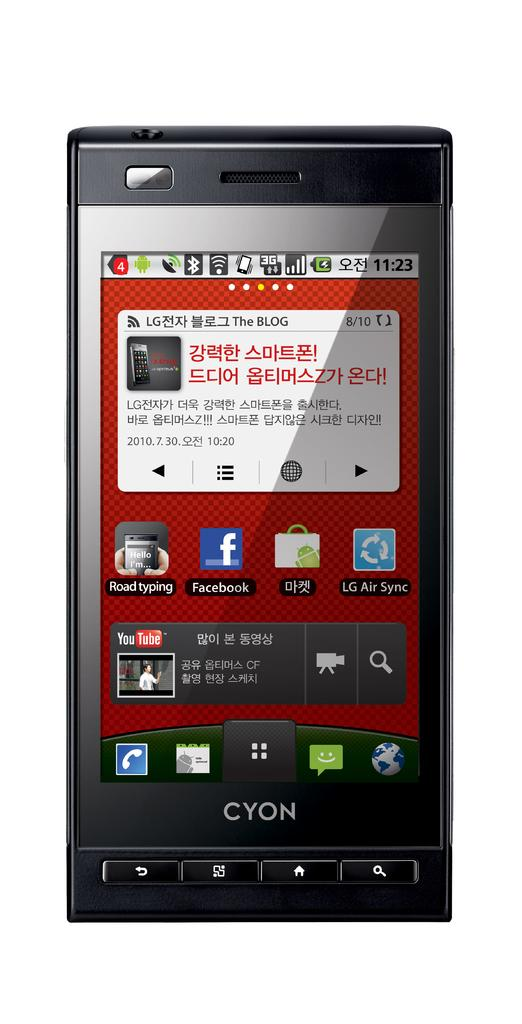<image>
Write a terse but informative summary of the picture. a cyon label on a phone with a white background 